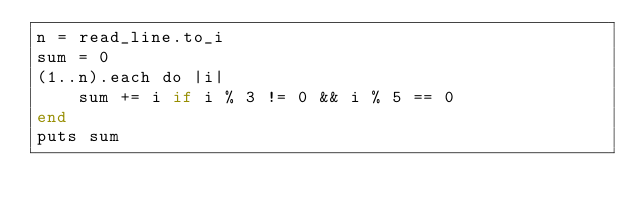Convert code to text. <code><loc_0><loc_0><loc_500><loc_500><_Crystal_>n = read_line.to_i
sum = 0
(1..n).each do |i|
    sum += i if i % 3 != 0 && i % 5 == 0
end
puts sum</code> 